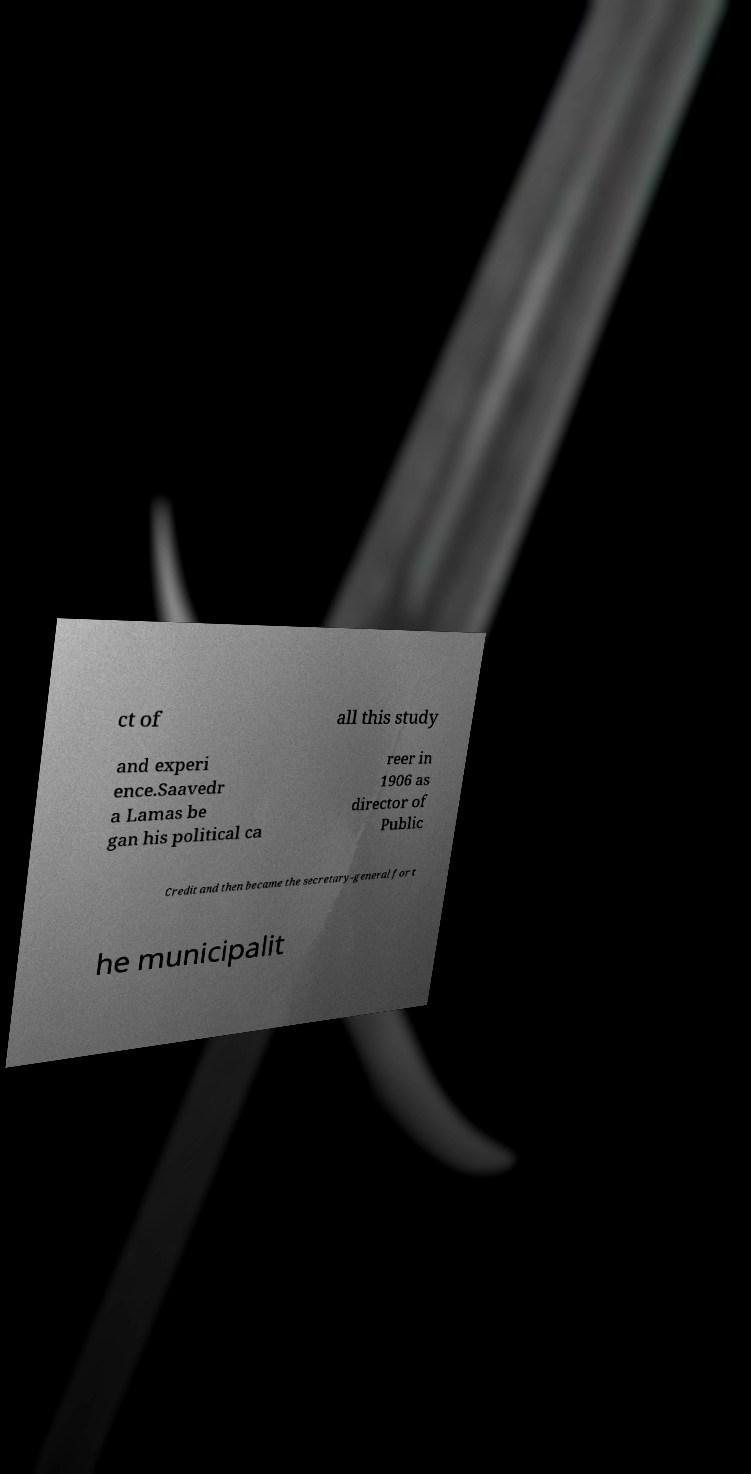Could you assist in decoding the text presented in this image and type it out clearly? ct of all this study and experi ence.Saavedr a Lamas be gan his political ca reer in 1906 as director of Public Credit and then became the secretary-general for t he municipalit 